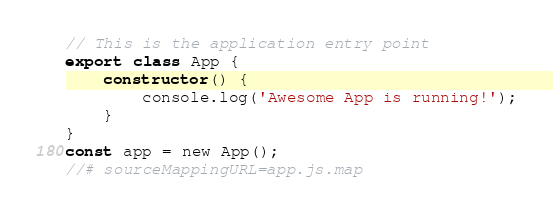<code> <loc_0><loc_0><loc_500><loc_500><_JavaScript_>// This is the application entry point
export class App {
    constructor() {
        console.log('Awesome App is running!');
    }
}
const app = new App();
//# sourceMappingURL=app.js.map</code> 